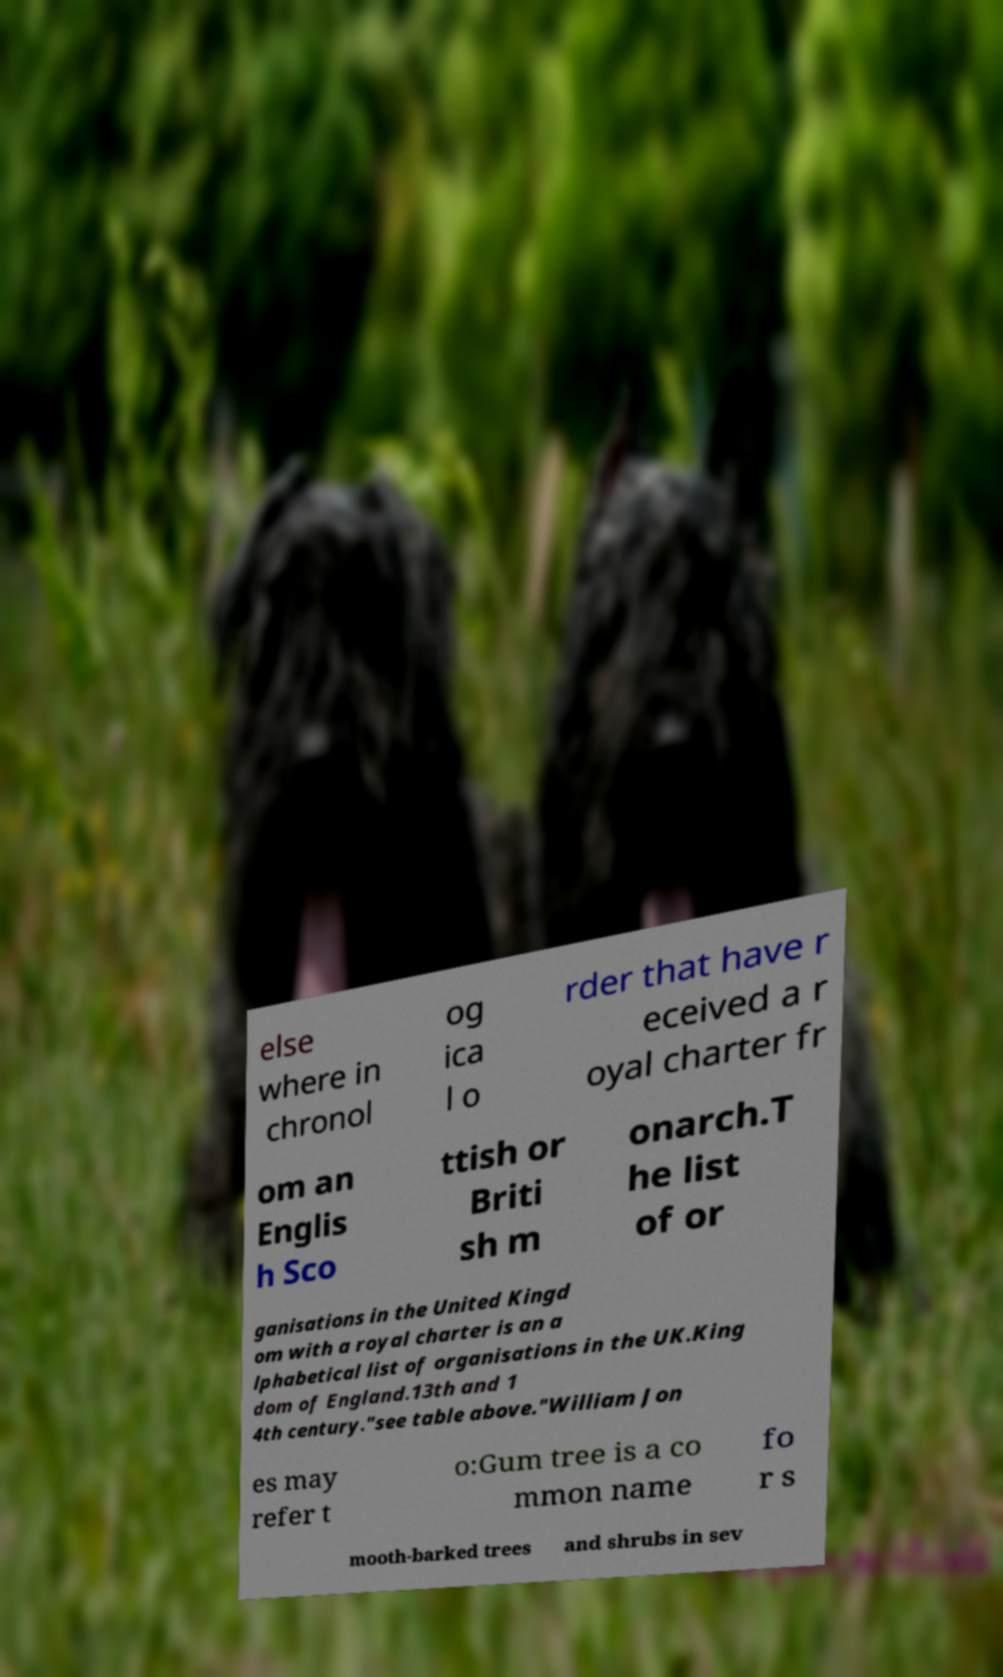Please identify and transcribe the text found in this image. else where in chronol og ica l o rder that have r eceived a r oyal charter fr om an Englis h Sco ttish or Briti sh m onarch.T he list of or ganisations in the United Kingd om with a royal charter is an a lphabetical list of organisations in the UK.King dom of England.13th and 1 4th century."see table above."William Jon es may refer t o:Gum tree is a co mmon name fo r s mooth-barked trees and shrubs in sev 